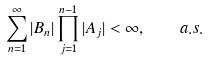Convert formula to latex. <formula><loc_0><loc_0><loc_500><loc_500>\sum _ { n = 1 } ^ { \infty } | B _ { n } | \prod _ { j = 1 } ^ { n - 1 } | A _ { j } | < \infty , \quad a . s .</formula> 